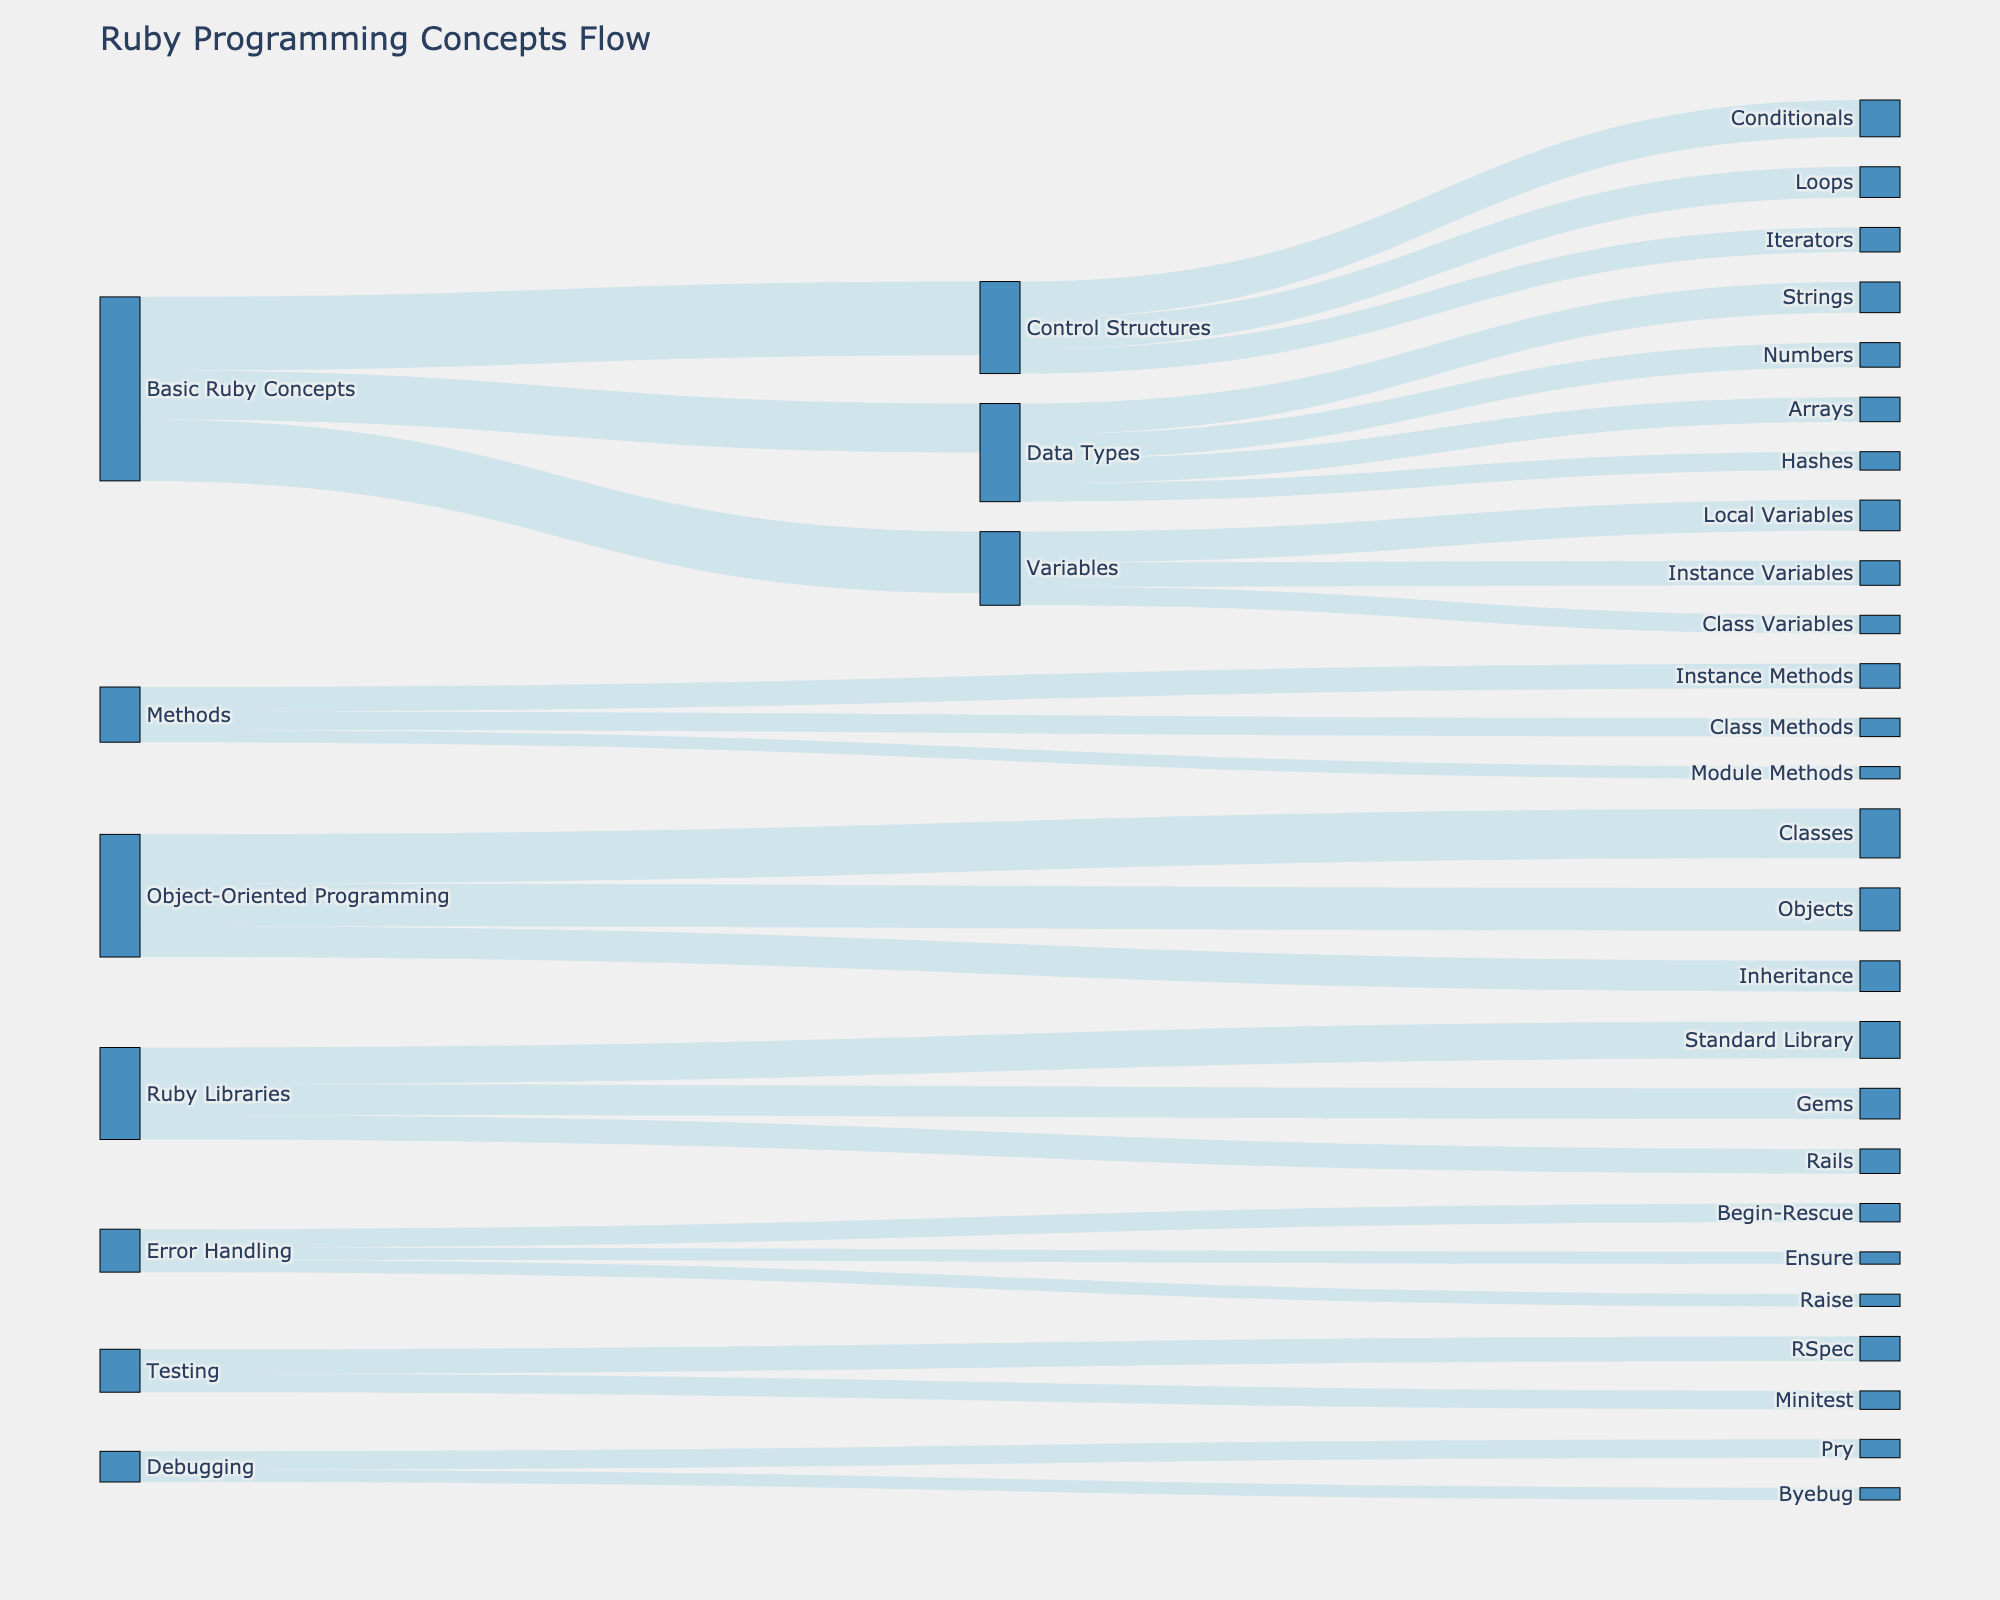What is the title of the figure? The title is found at the top of the figure and reads "Ruby Programming Concepts Flow"
Answer: Ruby Programming Concepts Flow How many nodes represent "Data Types"? Locate "Data Types" and count the nodes that stem from it. There are 4 target nodes: Numbers, Strings, Arrays, and Hashes
Answer: 4 Which concept has the highest value connection from "Basic Ruby Concepts"? Observe the connections from "Basic Ruby Concepts" and compare their values. The highest connection is to "Control Structures" with a value of 12
Answer: Control Structures What is the total value connected to "Variables"? Identify all connections to and from "Variables" and sum their values: Local Variables (5), Instance Variables (4), Class Variables (3). Total is 5 + 4 + 3 = 12
Answer: 12 Which "Control Structures" nodes have equal connection values? Look at the values of all nodes under "Control Structures". Both "Loops" and "Iterators" have values of 5
Answer: Loops, Iterators Between "Classes" and "Objects" under "Object-Oriented Programming", which one has a higher connection value? Compare the values of connections to "Classes" (8) and "Objects" (7). "Classes" has a higher value
Answer: Classes What are the nodes connected to "Error Handling"? Identify all target nodes stemming from "Error Handling". They are Begin-Rescue, Raise, and Ensure
Answer: Begin-Rescue, Raise, Ensure Are there more connections for "Testing" or "Debugging"? Count the connections for "Testing" (RSpec, Minitest) and "Debugging" (Pry, Byebug). "Testing" has 2 and "Debugging" also has 2, thus they are equal
Answer: Equal How does the value connected to "Gems" under "Ruby Libraries" compare to that of "Rails"? Compare the values of connections to "Gems" (5) and "Rails" (4). "Gems" has a value greater than "Rails"
Answer: Gems Which node under "Methods" has the lowest connection value? Identify the values for Instance Methods (4), Class Methods (3), and Module Methods (2). The lowest is Module Methods with a value of 2
Answer: Module Methods 